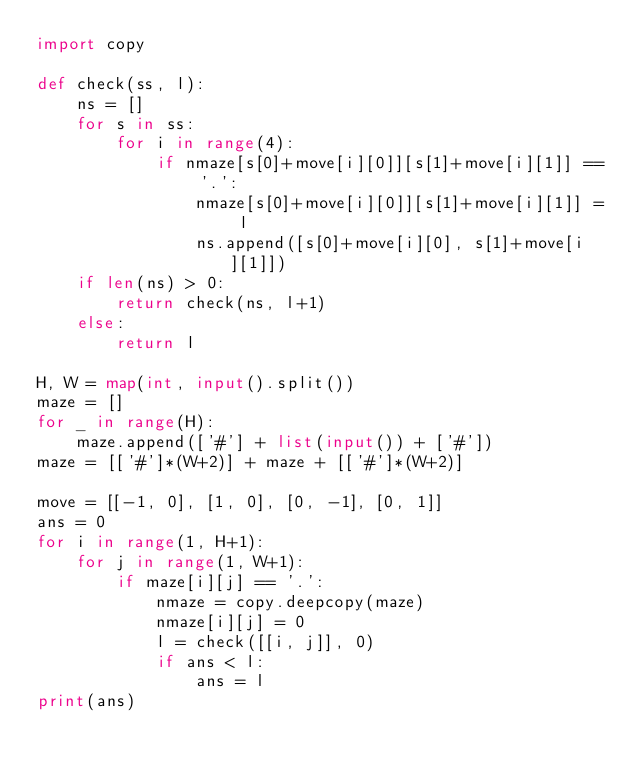<code> <loc_0><loc_0><loc_500><loc_500><_Python_>import copy

def check(ss, l):
    ns = []
    for s in ss:
        for i in range(4):
            if nmaze[s[0]+move[i][0]][s[1]+move[i][1]] == '.':
                nmaze[s[0]+move[i][0]][s[1]+move[i][1]] = l
                ns.append([s[0]+move[i][0], s[1]+move[i][1]])
    if len(ns) > 0:
        return check(ns, l+1)
    else:
        return l

H, W = map(int, input().split())
maze = []
for _ in range(H):
    maze.append(['#'] + list(input()) + ['#'])
maze = [['#']*(W+2)] + maze + [['#']*(W+2)]

move = [[-1, 0], [1, 0], [0, -1], [0, 1]]
ans = 0
for i in range(1, H+1):
    for j in range(1, W+1):
        if maze[i][j] == '.':
            nmaze = copy.deepcopy(maze)
            nmaze[i][j] = 0
            l = check([[i, j]], 0)
            if ans < l:
                ans = l
print(ans)</code> 